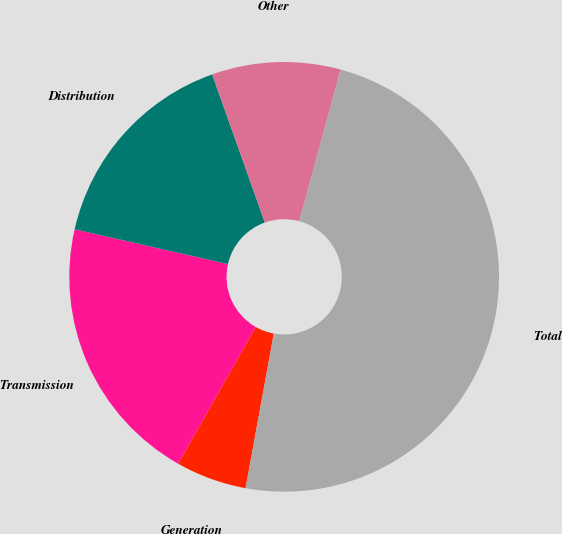Convert chart to OTSL. <chart><loc_0><loc_0><loc_500><loc_500><pie_chart><fcel>Generation<fcel>Transmission<fcel>Distribution<fcel>Other<fcel>Total<nl><fcel>5.34%<fcel>20.34%<fcel>16.01%<fcel>9.67%<fcel>48.64%<nl></chart> 